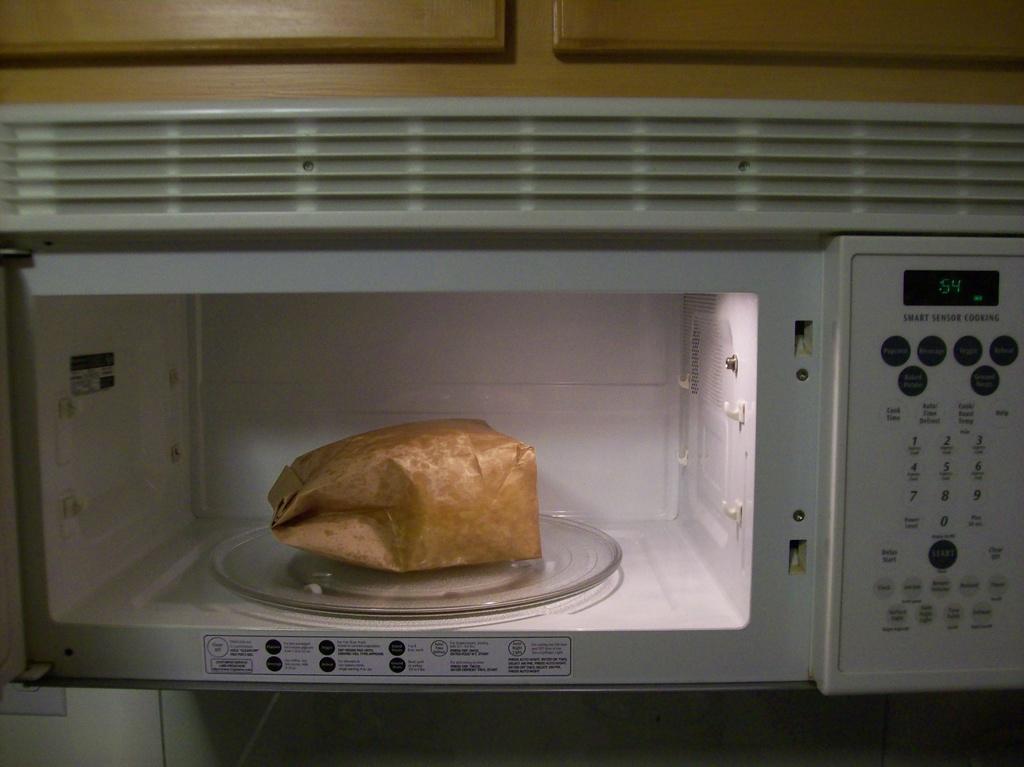In one or two sentences, can you explain what this image depicts? In this image we can see a paper bag is kept inside the microwave. Here we can see the wooden cupboards. 